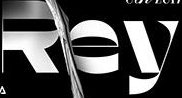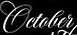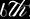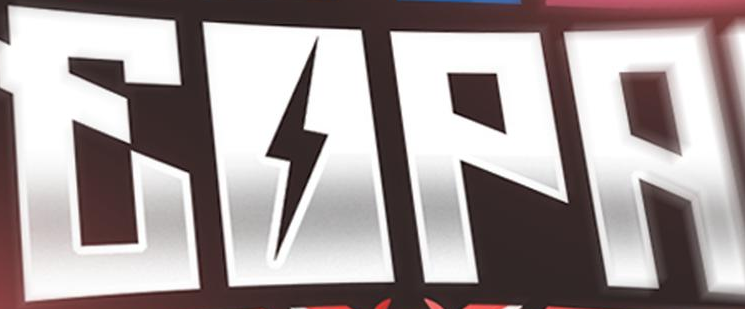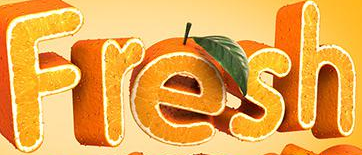Read the text content from these images in order, separated by a semicolon. Rey; October; 6th; EOPA; Fresh 